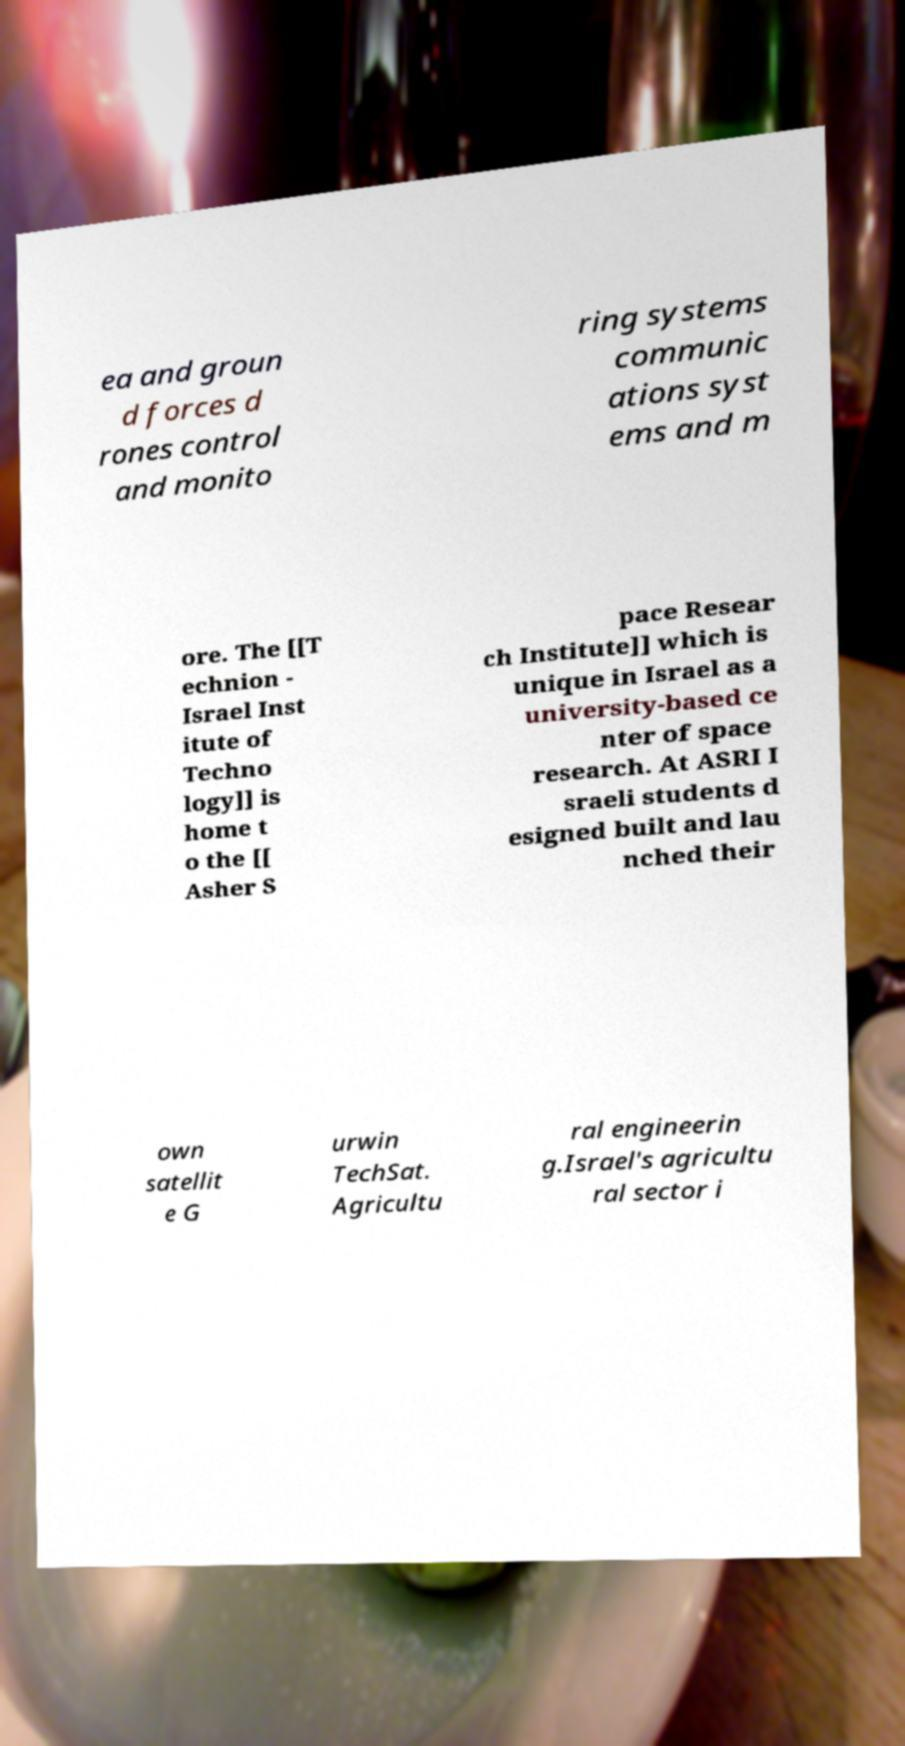Please read and relay the text visible in this image. What does it say? ea and groun d forces d rones control and monito ring systems communic ations syst ems and m ore. The [[T echnion - Israel Inst itute of Techno logy]] is home t o the [[ Asher S pace Resear ch Institute]] which is unique in Israel as a university-based ce nter of space research. At ASRI I sraeli students d esigned built and lau nched their own satellit e G urwin TechSat. Agricultu ral engineerin g.Israel's agricultu ral sector i 